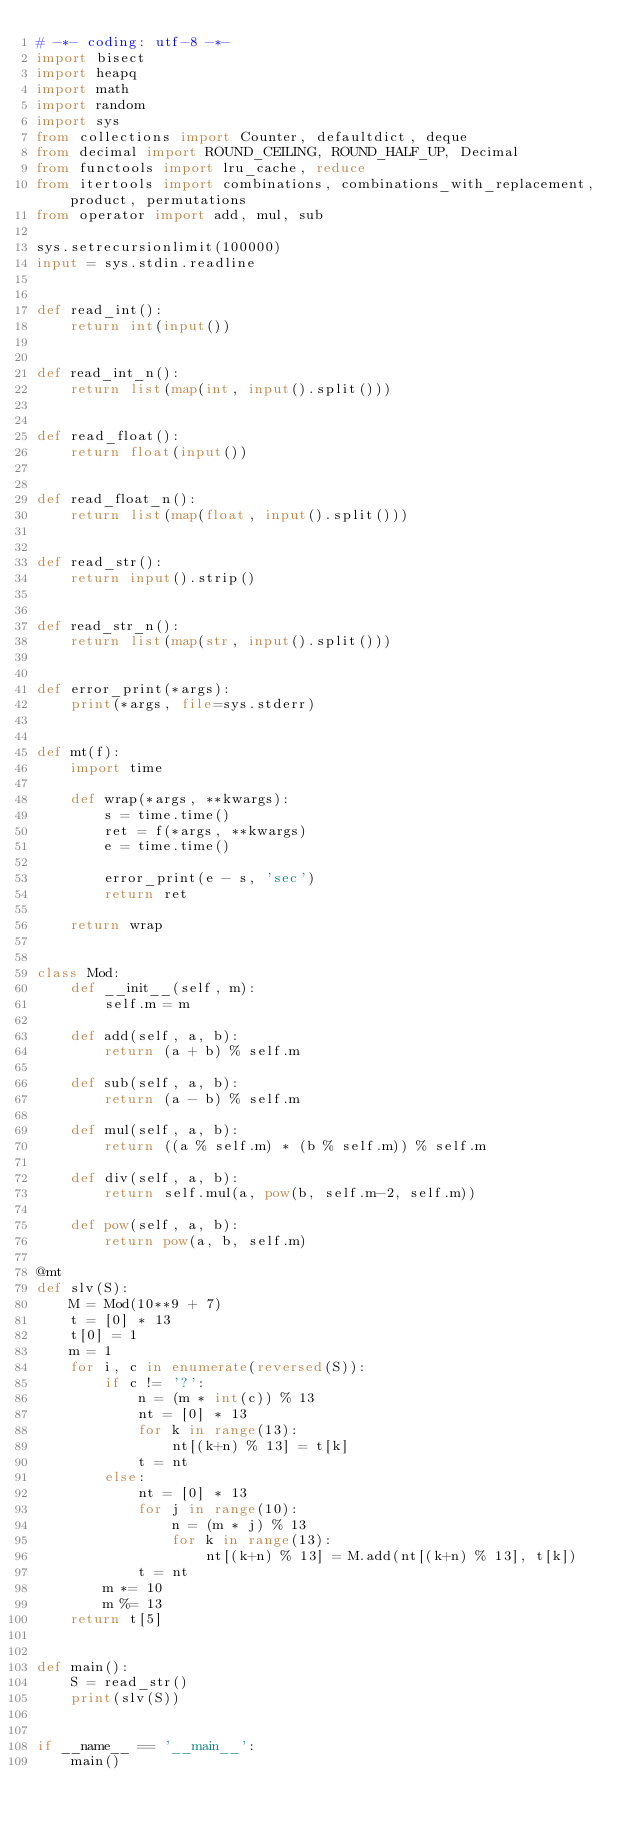<code> <loc_0><loc_0><loc_500><loc_500><_Python_># -*- coding: utf-8 -*-
import bisect
import heapq
import math
import random
import sys
from collections import Counter, defaultdict, deque
from decimal import ROUND_CEILING, ROUND_HALF_UP, Decimal
from functools import lru_cache, reduce
from itertools import combinations, combinations_with_replacement, product, permutations
from operator import add, mul, sub

sys.setrecursionlimit(100000)
input = sys.stdin.readline


def read_int():
    return int(input())


def read_int_n():
    return list(map(int, input().split()))


def read_float():
    return float(input())


def read_float_n():
    return list(map(float, input().split()))


def read_str():
    return input().strip()


def read_str_n():
    return list(map(str, input().split()))


def error_print(*args):
    print(*args, file=sys.stderr)


def mt(f):
    import time

    def wrap(*args, **kwargs):
        s = time.time()
        ret = f(*args, **kwargs)
        e = time.time()

        error_print(e - s, 'sec')
        return ret

    return wrap


class Mod:
    def __init__(self, m):
        self.m = m

    def add(self, a, b):
        return (a + b) % self.m

    def sub(self, a, b):
        return (a - b) % self.m

    def mul(self, a, b):
        return ((a % self.m) * (b % self.m)) % self.m

    def div(self, a, b):
        return self.mul(a, pow(b, self.m-2, self.m))

    def pow(self, a, b):
        return pow(a, b, self.m)

@mt
def slv(S):
    M = Mod(10**9 + 7)
    t = [0] * 13
    t[0] = 1
    m = 1
    for i, c in enumerate(reversed(S)):
        if c != '?':
            n = (m * int(c)) % 13
            nt = [0] * 13
            for k in range(13):
                nt[(k+n) % 13] = t[k]
            t = nt
        else:
            nt = [0] * 13
            for j in range(10):
                n = (m * j) % 13
                for k in range(13):
                    nt[(k+n) % 13] = M.add(nt[(k+n) % 13], t[k])
            t = nt
        m *= 10
        m %= 13
    return t[5]


def main():
    S = read_str()
    print(slv(S))


if __name__ == '__main__':
    main()
</code> 